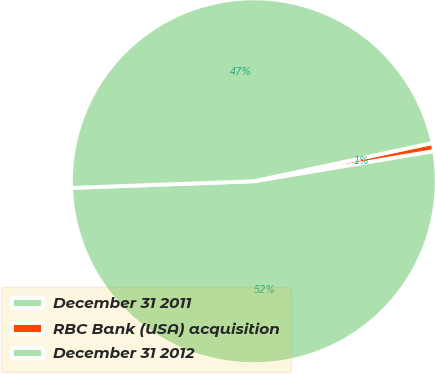<chart> <loc_0><loc_0><loc_500><loc_500><pie_chart><fcel>December 31 2011<fcel>RBC Bank (USA) acquisition<fcel>December 31 2012<nl><fcel>52.07%<fcel>0.71%<fcel>47.22%<nl></chart> 